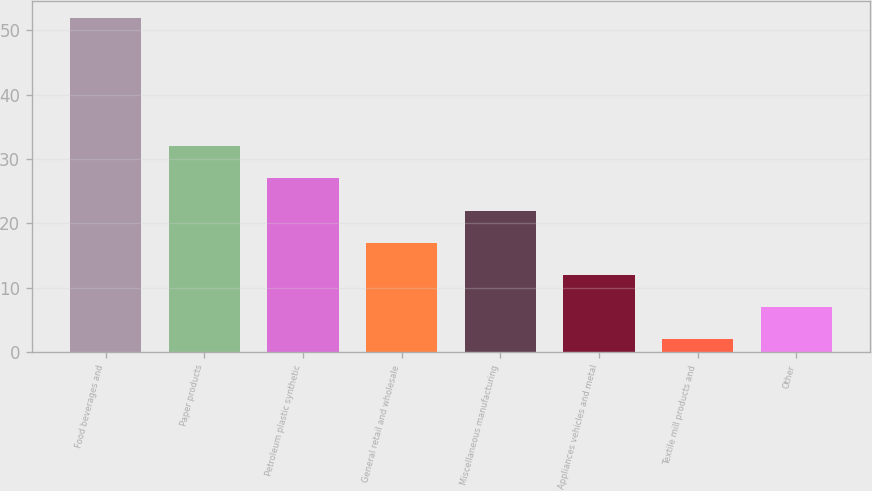Convert chart. <chart><loc_0><loc_0><loc_500><loc_500><bar_chart><fcel>Food beverages and<fcel>Paper products<fcel>Petroleum plastic synthetic<fcel>General retail and wholesale<fcel>Miscellaneous manufacturing<fcel>Appliances vehicles and metal<fcel>Textile mill products and<fcel>Other<nl><fcel>52<fcel>32<fcel>27<fcel>17<fcel>22<fcel>12<fcel>2<fcel>7<nl></chart> 